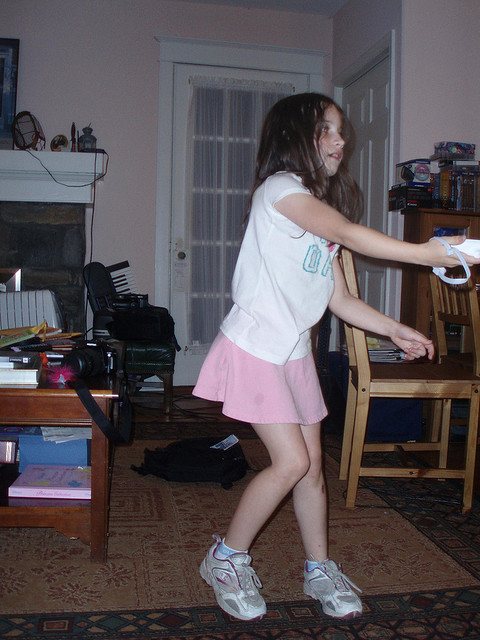<image>What brand are the girl's shoes? I don't know what brand the girl's shoes are. They could be Nike, Reebok, Adidas, Sketchers, or Asics. How old is the girl? I don't know how old the girl is. She can be any age between 7 and 12. What brand are the girl's shoes? I don't know what brand are the girl's shoes. It can be Nike, Reebok, Adidas, Sketchers, or Asics. How old is the girl? I don't know how old the girl is. It can be seen as 8, 12, 10, 7 or 9. 